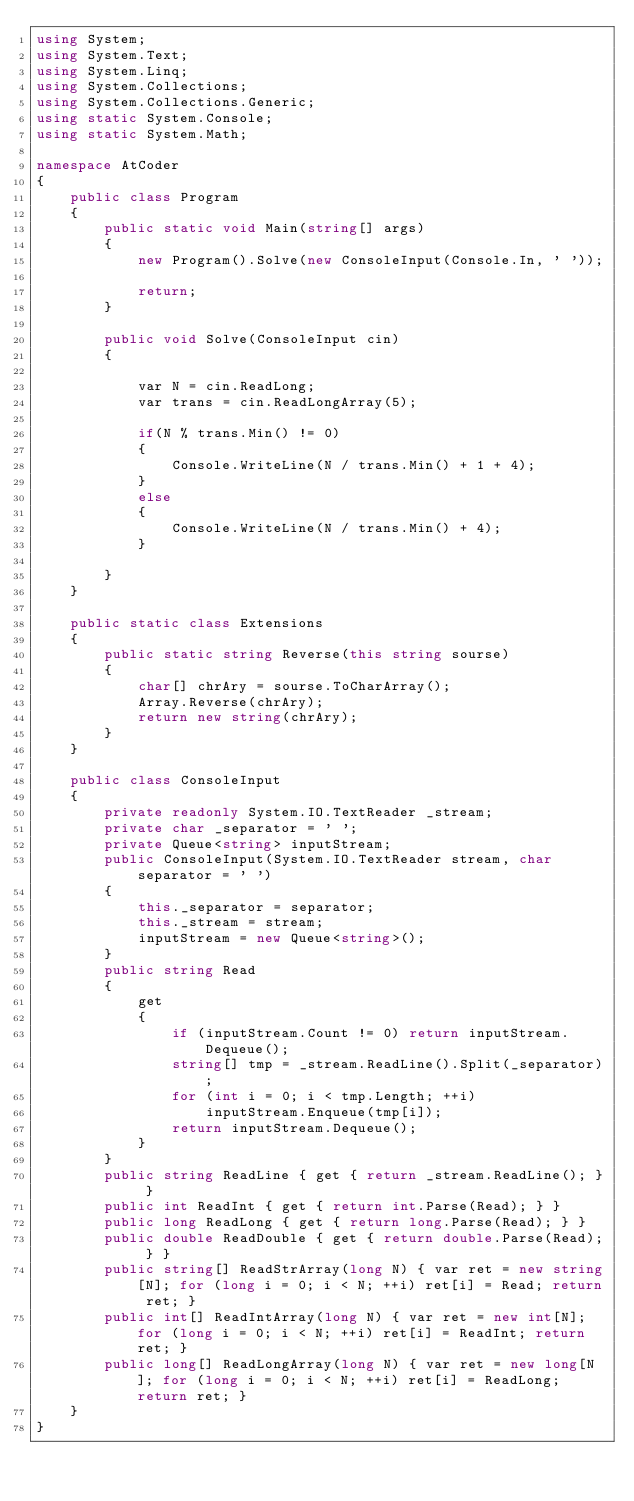<code> <loc_0><loc_0><loc_500><loc_500><_C#_>using System;
using System.Text;
using System.Linq;
using System.Collections;
using System.Collections.Generic;
using static System.Console;
using static System.Math;

namespace AtCoder
{
    public class Program
    {
        public static void Main(string[] args)
        {
            new Program().Solve(new ConsoleInput(Console.In, ' '));

            return;
        }

        public void Solve(ConsoleInput cin)
        {

            var N = cin.ReadLong;
            var trans = cin.ReadLongArray(5);

            if(N % trans.Min() != 0)
            {
                Console.WriteLine(N / trans.Min() + 1 + 4);
            }
            else
            {
                Console.WriteLine(N / trans.Min() + 4);
            }

        }
    }

    public static class Extensions
    {
        public static string Reverse(this string sourse)
        {
            char[] chrAry = sourse.ToCharArray();
            Array.Reverse(chrAry);
            return new string(chrAry);
        }
    }

    public class ConsoleInput
    {
        private readonly System.IO.TextReader _stream;
        private char _separator = ' ';
        private Queue<string> inputStream;
        public ConsoleInput(System.IO.TextReader stream, char separator = ' ')
        {
            this._separator = separator;
            this._stream = stream;
            inputStream = new Queue<string>();
        }
        public string Read
        {
            get
            {
                if (inputStream.Count != 0) return inputStream.Dequeue();
                string[] tmp = _stream.ReadLine().Split(_separator);
                for (int i = 0; i < tmp.Length; ++i)
                    inputStream.Enqueue(tmp[i]);
                return inputStream.Dequeue();
            }
        }
        public string ReadLine { get { return _stream.ReadLine(); } }
        public int ReadInt { get { return int.Parse(Read); } }
        public long ReadLong { get { return long.Parse(Read); } }
        public double ReadDouble { get { return double.Parse(Read); } }
        public string[] ReadStrArray(long N) { var ret = new string[N]; for (long i = 0; i < N; ++i) ret[i] = Read; return ret; }
        public int[] ReadIntArray(long N) { var ret = new int[N]; for (long i = 0; i < N; ++i) ret[i] = ReadInt; return ret; }
        public long[] ReadLongArray(long N) { var ret = new long[N]; for (long i = 0; i < N; ++i) ret[i] = ReadLong; return ret; }
    }
}
</code> 